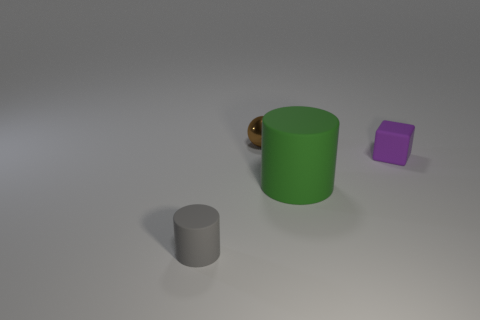What is the object that is in front of the big matte thing made of?
Keep it short and to the point. Rubber. Is there a yellow ball that has the same size as the metal thing?
Give a very brief answer. No. There is a brown object; does it have the same shape as the small rubber thing that is behind the small gray matte object?
Provide a succinct answer. No. There is a cylinder that is right of the small gray thing; does it have the same size as the thing left of the tiny metal object?
Ensure brevity in your answer.  No. How many other objects are the same shape as the purple rubber object?
Give a very brief answer. 0. There is a cylinder to the right of the rubber object that is on the left side of the small ball; what is it made of?
Make the answer very short. Rubber. What number of metallic objects are big green cylinders or red spheres?
Your answer should be compact. 0. Is there any other thing that is made of the same material as the brown sphere?
Your answer should be compact. No. There is a block that is right of the sphere; is there a cube in front of it?
Your answer should be compact. No. How many things are either matte objects that are left of the green object or matte cylinders that are left of the big green thing?
Your answer should be very brief. 1. 